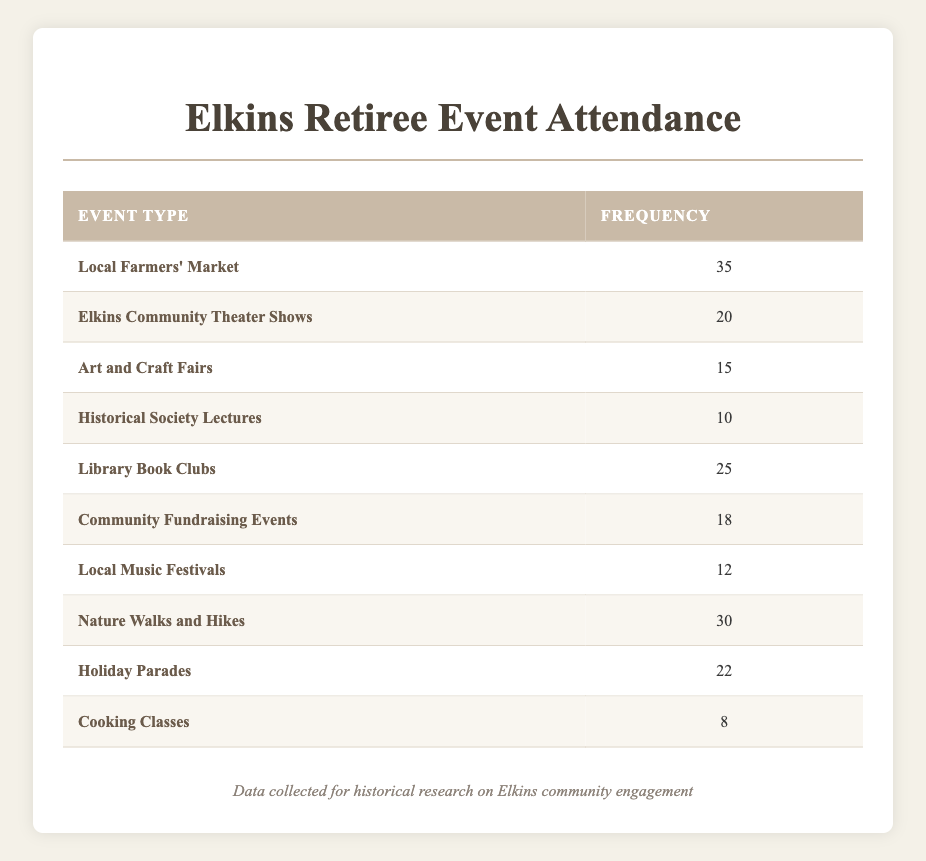What is the frequency of attendance for Local Farmers' Market? The frequency of attendance for Local Farmers' Market is explicitly stated in the table under the "Frequency" column corresponding to the event type.
Answer: 35 How many retirees attended Library Book Clubs? The frequency of attendance for Library Book Clubs can be found directly in the table next to the event type in the corresponding row.
Answer: 25 What is the total frequency of retirees attending Nature Walks and Hikes and Local Music Festivals combined? To find the combined frequency, look up both event types: Nature Walks and Hikes (30) and Local Music Festivals (12). Adding them together gives 30 + 12 = 42.
Answer: 42 Is the frequency of attendance for Cooking Classes greater than 10? The frequency for Cooking Classes is 8, as listed in the table, which is less than 10. Therefore, the statement is false.
Answer: No What is the event type with the lowest frequency of attendance? Review the frequency for all event types in the table. Cooking Classes has the lowest value, which is 8.
Answer: Cooking Classes What percentage of retirees attended the Elkins Community Theater Shows compared to the total event frequencies? First, sum all the frequencies: 35 + 20 + 15 + 10 + 25 + 18 + 12 + 30 + 22 + 8 =  270. The frequency for Elkins Community Theater Shows is 20. The percentage is (20/270) * 100 ≈ 7.41%.
Answer: Approximately 7.41% What is the difference in frequency between the highest and lowest attended events? The highest attended event is Local Farmers' Market with a frequency of 35, and the lowest is Cooking Classes with a frequency of 8. The difference is 35 - 8 = 27.
Answer: 27 Are there more retirees attending Holiday Parades or Elkins Community Theater Shows? Holiday Parades has a frequency of 22, while Elkins Community Theater Shows has a frequency of 20. Since 22 is greater than 20, the answer is yes.
Answer: Yes Which events have a frequency equal to or greater than 20? Check the table for frequencies of each event. The events with a frequency of 20 or more are: Local Farmers' Market (35), Library Book Clubs (25), Holiday Parades (22), and Elkins Community Theater Shows (20).
Answer: Local Farmers' Market, Library Book Clubs, Holiday Parades, Elkins Community Theater Shows 